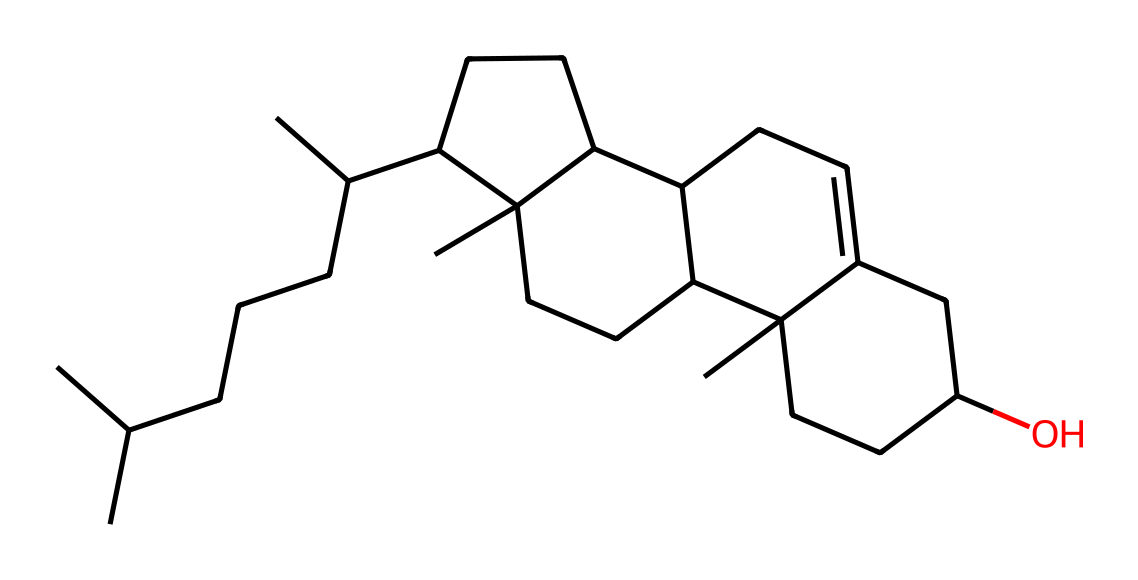What is the molecular formula of cholesterol? The molecular formula can be derived from counting the number of carbon (C), hydrogen (H), and oxygen (O) atoms present in the structure. The structure contains 27 carbon atoms, 46 hydrogen atoms, and 1 oxygen atom, leading to the formula C27H46O.
Answer: C27H46O How many rings are present in the structure of cholesterol? By analyzing the visual representation, one can identify the distinct ring structures in cholesterol. There are four interconnected rings commonly referred to as the steroid nucleus in this molecule.
Answer: four What type of lipid is cholesterol classified as? Cholesterol is a type of lipid known as a sterol due to its polycyclic structure and the presence of a hydroxyl group (-OH). This classification is based on the structural features and functional properties of the molecule.
Answer: sterol How many double bonds are present in the cholesterol structure? Upon examining the structure, it's essential to count the double bonds. In cholesterol, there is one double bond located within one of the rings.
Answer: one What functional group is present in cholesterol? The presence of a hydroxyl group (-OH) is a defining feature of cholesterol's functional group. It indicates that cholesterol has amphipathic properties, important for its role in cell membranes.
Answer: hydroxyl group What is the primary role of cholesterol in biological systems? Cholesterol primarily functions as a component of cell membranes, contributing to membrane fluidity and integrity, as well as serving as a precursor for steroid hormones. This role is critical for maintaining cellular structure and signaling.
Answer: membrane component 